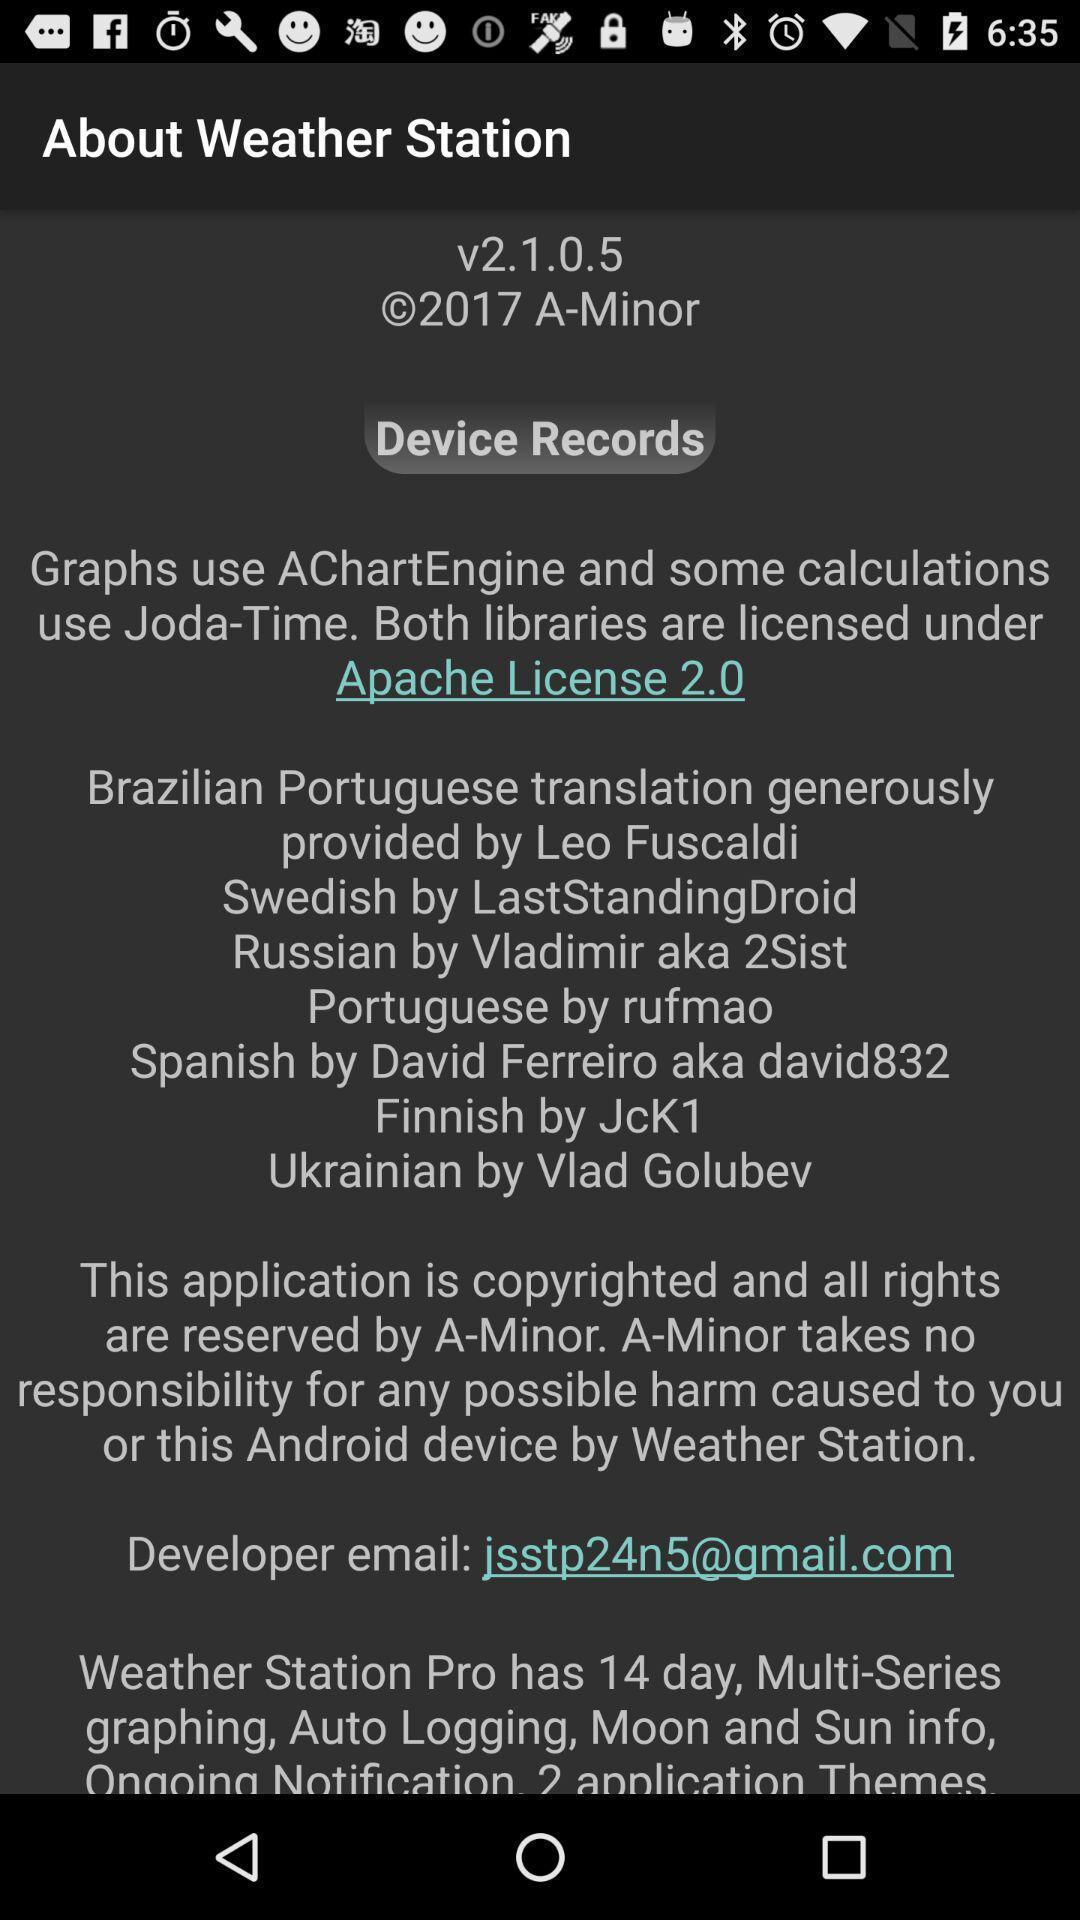What is the overall content of this screenshot? Page displaying details pf a weather station. 